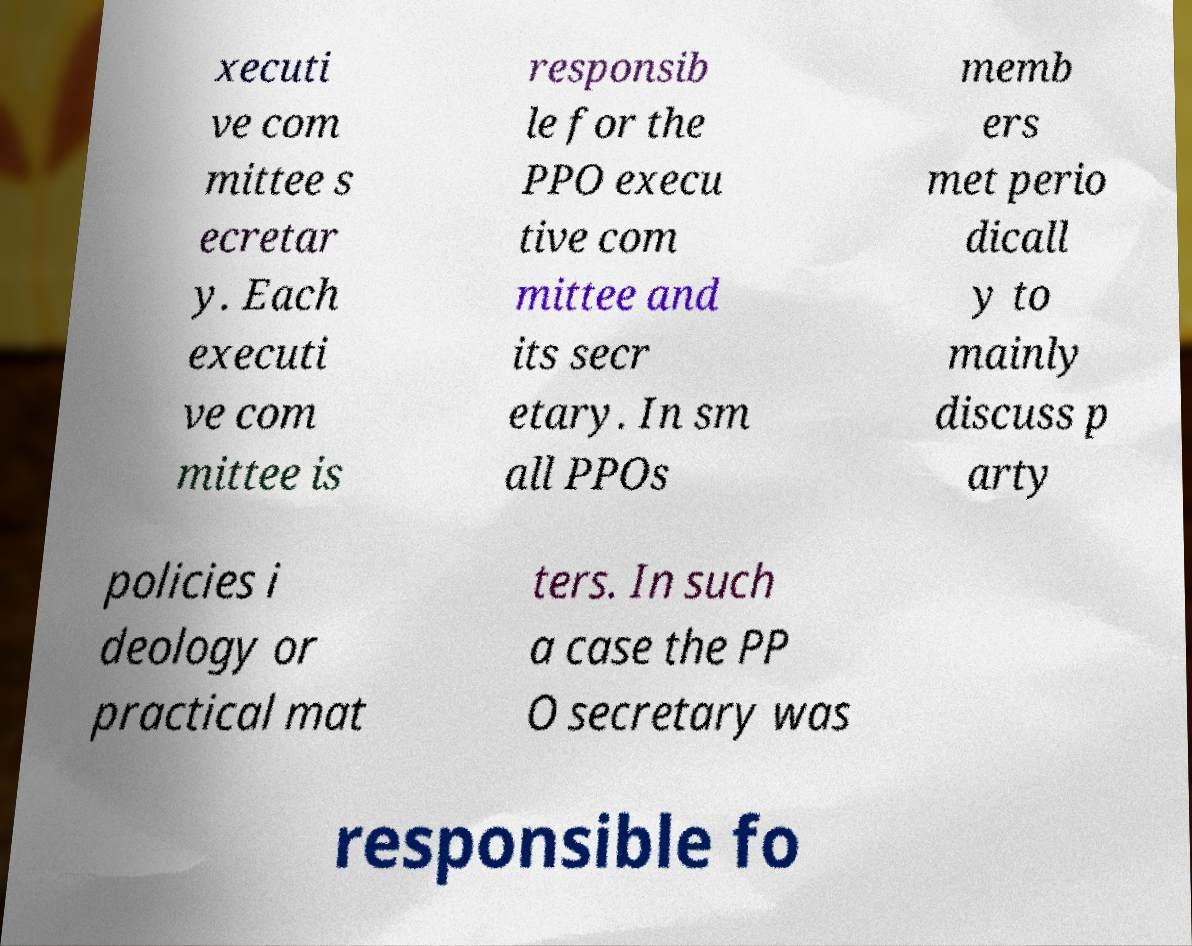I need the written content from this picture converted into text. Can you do that? xecuti ve com mittee s ecretar y. Each executi ve com mittee is responsib le for the PPO execu tive com mittee and its secr etary. In sm all PPOs memb ers met perio dicall y to mainly discuss p arty policies i deology or practical mat ters. In such a case the PP O secretary was responsible fo 